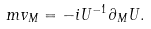Convert formula to latex. <formula><loc_0><loc_0><loc_500><loc_500>m v _ { M } = - i U ^ { - 1 } \partial _ { M } U .</formula> 